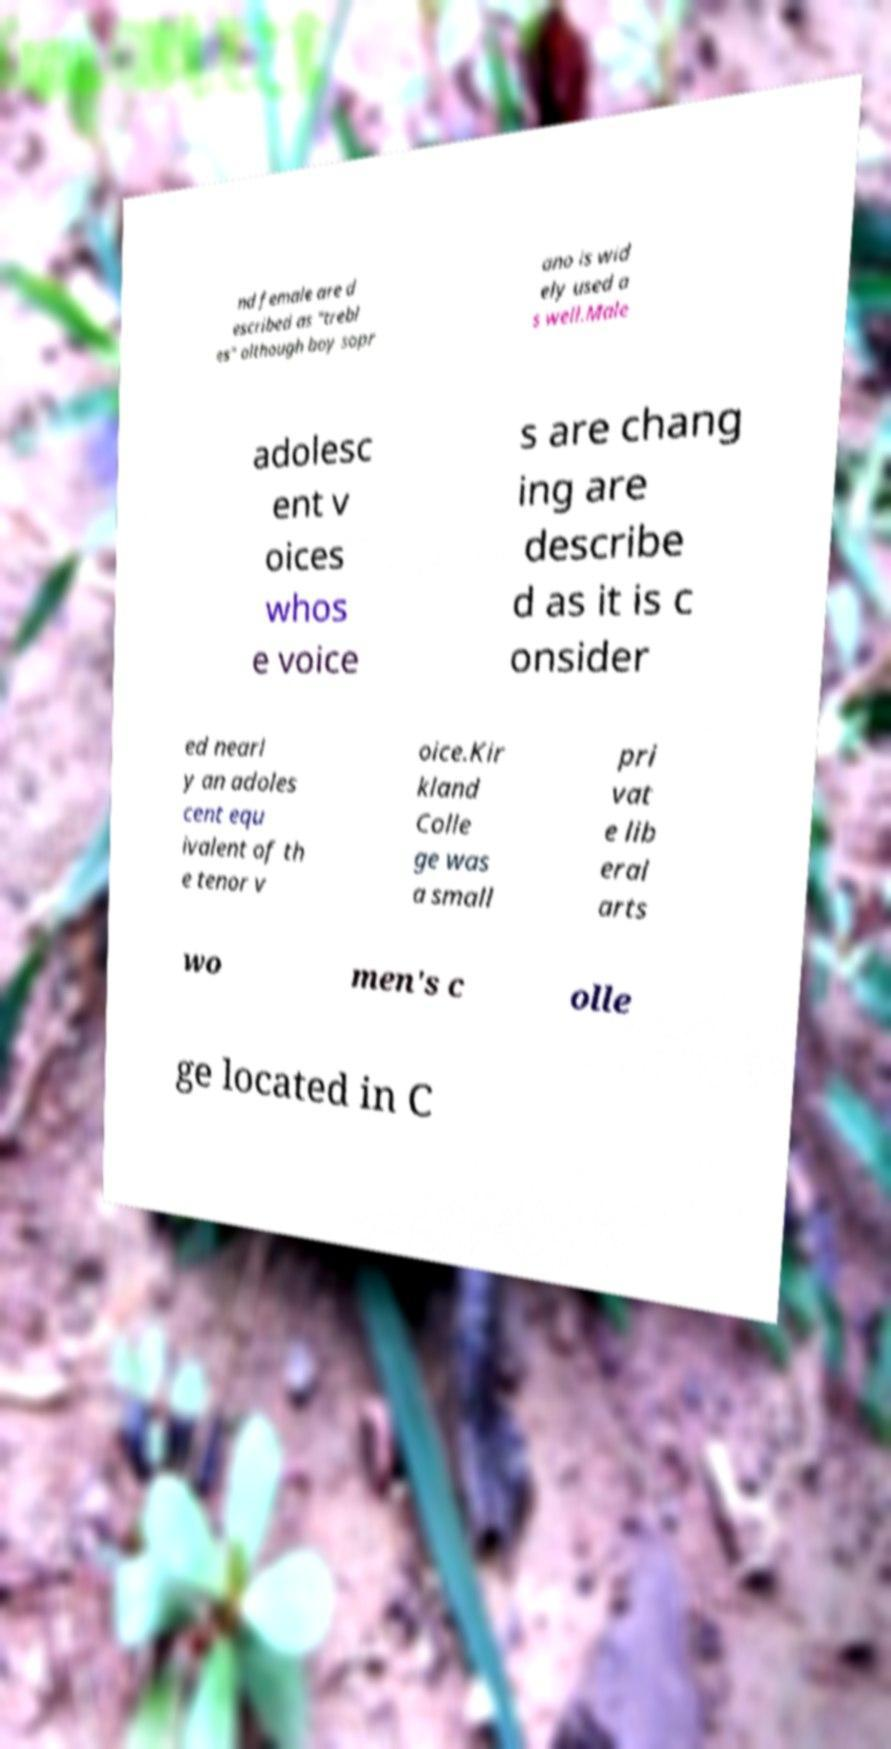There's text embedded in this image that I need extracted. Can you transcribe it verbatim? nd female are d escribed as "trebl es" although boy sopr ano is wid ely used a s well.Male adolesc ent v oices whos e voice s are chang ing are describe d as it is c onsider ed nearl y an adoles cent equ ivalent of th e tenor v oice.Kir kland Colle ge was a small pri vat e lib eral arts wo men's c olle ge located in C 